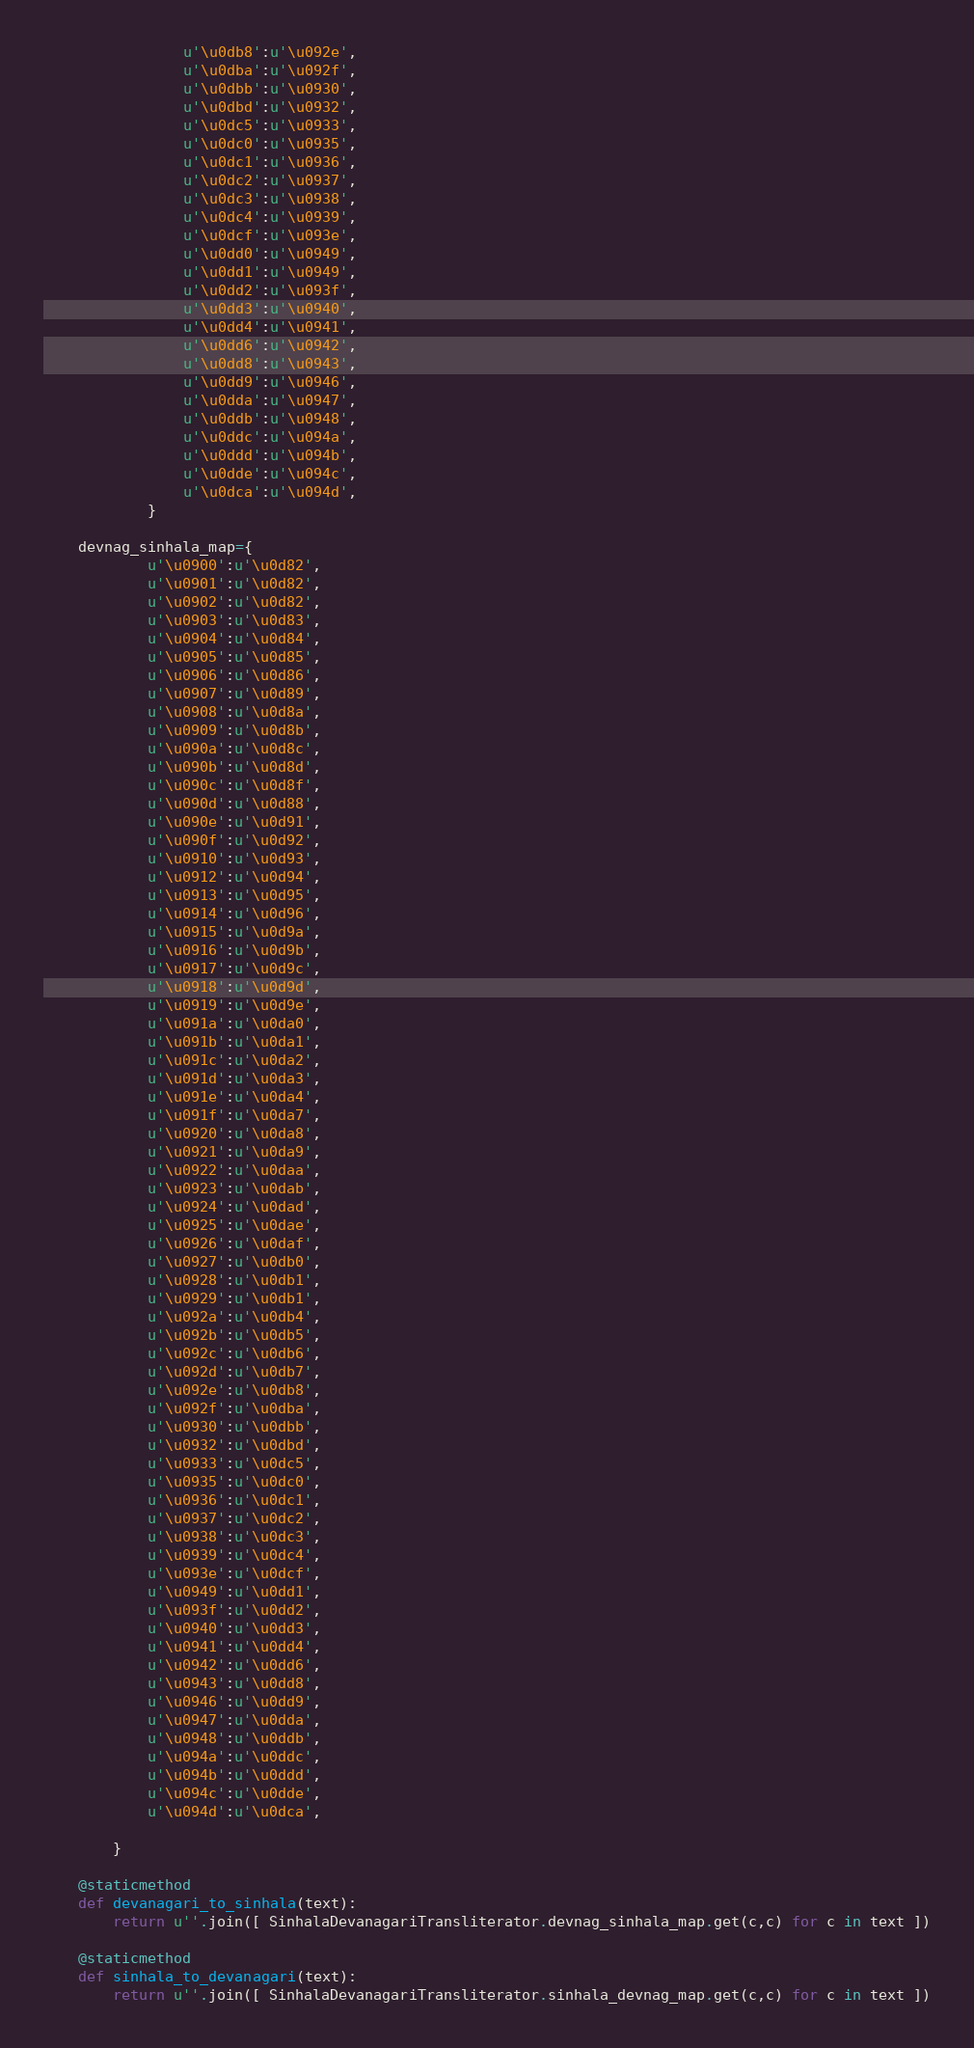<code> <loc_0><loc_0><loc_500><loc_500><_Python_>                u'\u0db8':u'\u092e',
                u'\u0dba':u'\u092f',
                u'\u0dbb':u'\u0930',
                u'\u0dbd':u'\u0932',
                u'\u0dc5':u'\u0933',
                u'\u0dc0':u'\u0935',
                u'\u0dc1':u'\u0936',
                u'\u0dc2':u'\u0937',
                u'\u0dc3':u'\u0938',
                u'\u0dc4':u'\u0939',
                u'\u0dcf':u'\u093e',
                u'\u0dd0':u'\u0949',
                u'\u0dd1':u'\u0949',
                u'\u0dd2':u'\u093f',
                u'\u0dd3':u'\u0940',
                u'\u0dd4':u'\u0941',
                u'\u0dd6':u'\u0942',
                u'\u0dd8':u'\u0943',
                u'\u0dd9':u'\u0946',
                u'\u0dda':u'\u0947',
                u'\u0ddb':u'\u0948',
                u'\u0ddc':u'\u094a',
                u'\u0ddd':u'\u094b',
                u'\u0dde':u'\u094c',
                u'\u0dca':u'\u094d',
            }

    devnag_sinhala_map={
            u'\u0900':u'\u0d82', 
            u'\u0901':u'\u0d82',
            u'\u0902':u'\u0d82',
            u'\u0903':u'\u0d83',
            u'\u0904':u'\u0d84',
            u'\u0905':u'\u0d85',
            u'\u0906':u'\u0d86',
            u'\u0907':u'\u0d89',
            u'\u0908':u'\u0d8a',
            u'\u0909':u'\u0d8b',
            u'\u090a':u'\u0d8c',
            u'\u090b':u'\u0d8d',
            u'\u090c':u'\u0d8f',
            u'\u090d':u'\u0d88',
            u'\u090e':u'\u0d91',
            u'\u090f':u'\u0d92',
            u'\u0910':u'\u0d93',
            u'\u0912':u'\u0d94',
            u'\u0913':u'\u0d95',
            u'\u0914':u'\u0d96',
            u'\u0915':u'\u0d9a',
            u'\u0916':u'\u0d9b',
            u'\u0917':u'\u0d9c',
            u'\u0918':u'\u0d9d',
            u'\u0919':u'\u0d9e',
            u'\u091a':u'\u0da0',
            u'\u091b':u'\u0da1',
            u'\u091c':u'\u0da2',
            u'\u091d':u'\u0da3',
            u'\u091e':u'\u0da4',
            u'\u091f':u'\u0da7',
            u'\u0920':u'\u0da8',
            u'\u0921':u'\u0da9',
            u'\u0922':u'\u0daa',
            u'\u0923':u'\u0dab',
            u'\u0924':u'\u0dad',
            u'\u0925':u'\u0dae',
            u'\u0926':u'\u0daf',
            u'\u0927':u'\u0db0',
            u'\u0928':u'\u0db1',
            u'\u0929':u'\u0db1',
            u'\u092a':u'\u0db4',
            u'\u092b':u'\u0db5',
            u'\u092c':u'\u0db6',
            u'\u092d':u'\u0db7',
            u'\u092e':u'\u0db8',
            u'\u092f':u'\u0dba',
            u'\u0930':u'\u0dbb',
            u'\u0932':u'\u0dbd',
            u'\u0933':u'\u0dc5',
            u'\u0935':u'\u0dc0',
            u'\u0936':u'\u0dc1',
            u'\u0937':u'\u0dc2',
            u'\u0938':u'\u0dc3',
            u'\u0939':u'\u0dc4',
            u'\u093e':u'\u0dcf',
            u'\u0949':u'\u0dd1',
            u'\u093f':u'\u0dd2',
            u'\u0940':u'\u0dd3',
            u'\u0941':u'\u0dd4',
            u'\u0942':u'\u0dd6',
            u'\u0943':u'\u0dd8',
            u'\u0946':u'\u0dd9',
            u'\u0947':u'\u0dda',
            u'\u0948':u'\u0ddb',
            u'\u094a':u'\u0ddc',
            u'\u094b':u'\u0ddd',
            u'\u094c':u'\u0dde',
            u'\u094d':u'\u0dca',
            
        }

    @staticmethod
    def devanagari_to_sinhala(text):
        return u''.join([ SinhalaDevanagariTransliterator.devnag_sinhala_map.get(c,c) for c in text ])

    @staticmethod
    def sinhala_to_devanagari(text):
        return u''.join([ SinhalaDevanagariTransliterator.sinhala_devnag_map.get(c,c) for c in text ])

</code> 